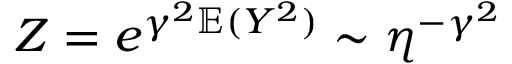Convert formula to latex. <formula><loc_0><loc_0><loc_500><loc_500>Z = e ^ { \gamma ^ { 2 } \mathbb { E } ( Y ^ { 2 } ) } \sim \eta ^ { - \gamma ^ { 2 } }</formula> 